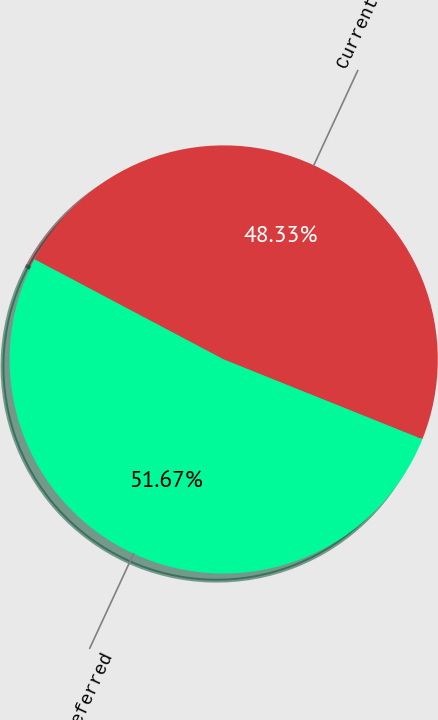Convert chart to OTSL. <chart><loc_0><loc_0><loc_500><loc_500><pie_chart><fcel>Current<fcel>Deferred<nl><fcel>48.33%<fcel>51.67%<nl></chart> 